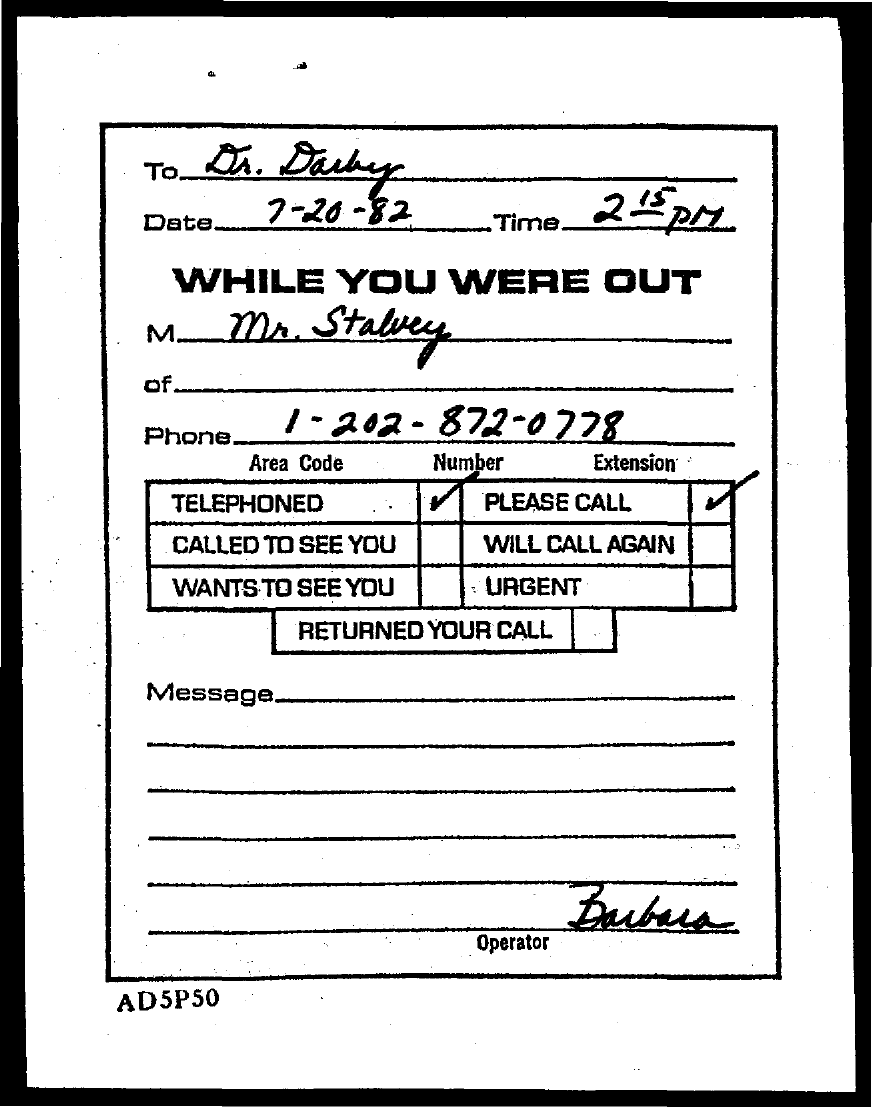List a handful of essential elements in this visual. The message is from Mr. Stalvey. The phone number is 1-202-872-0778. This message is addressed to Dr. Darby. The date is 7-20-82. The operator is Barbara. 